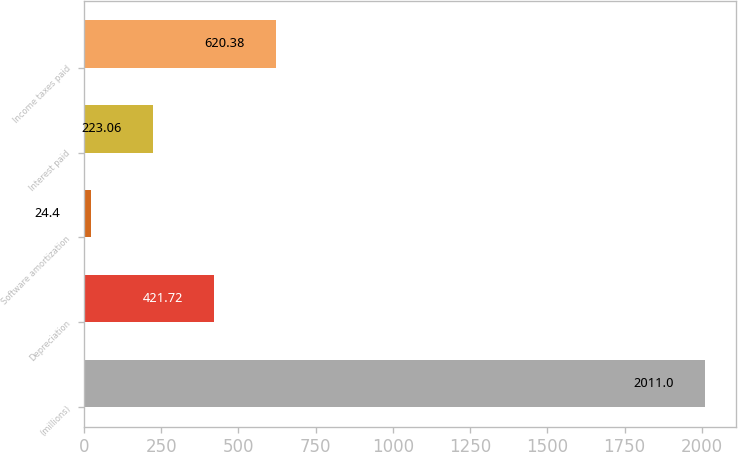Convert chart. <chart><loc_0><loc_0><loc_500><loc_500><bar_chart><fcel>(millions)<fcel>Depreciation<fcel>Software amortization<fcel>Interest paid<fcel>Income taxes paid<nl><fcel>2011<fcel>421.72<fcel>24.4<fcel>223.06<fcel>620.38<nl></chart> 